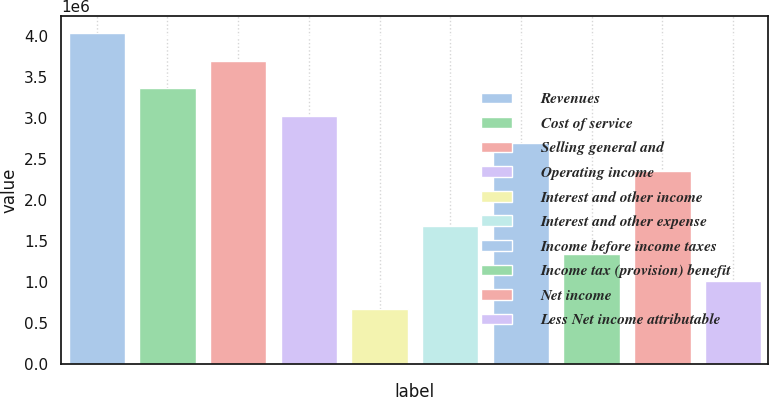Convert chart to OTSL. <chart><loc_0><loc_0><loc_500><loc_500><bar_chart><fcel>Revenues<fcel>Cost of service<fcel>Selling general and<fcel>Operating income<fcel>Interest and other income<fcel>Interest and other expense<fcel>Income before income taxes<fcel>Income tax (provision) benefit<fcel>Net income<fcel>Less Net income attributable<nl><fcel>4.03964e+06<fcel>3.36637e+06<fcel>3.703e+06<fcel>3.02973e+06<fcel>673275<fcel>1.68318e+06<fcel>2.69309e+06<fcel>1.34655e+06<fcel>2.35646e+06<fcel>1.00991e+06<nl></chart> 